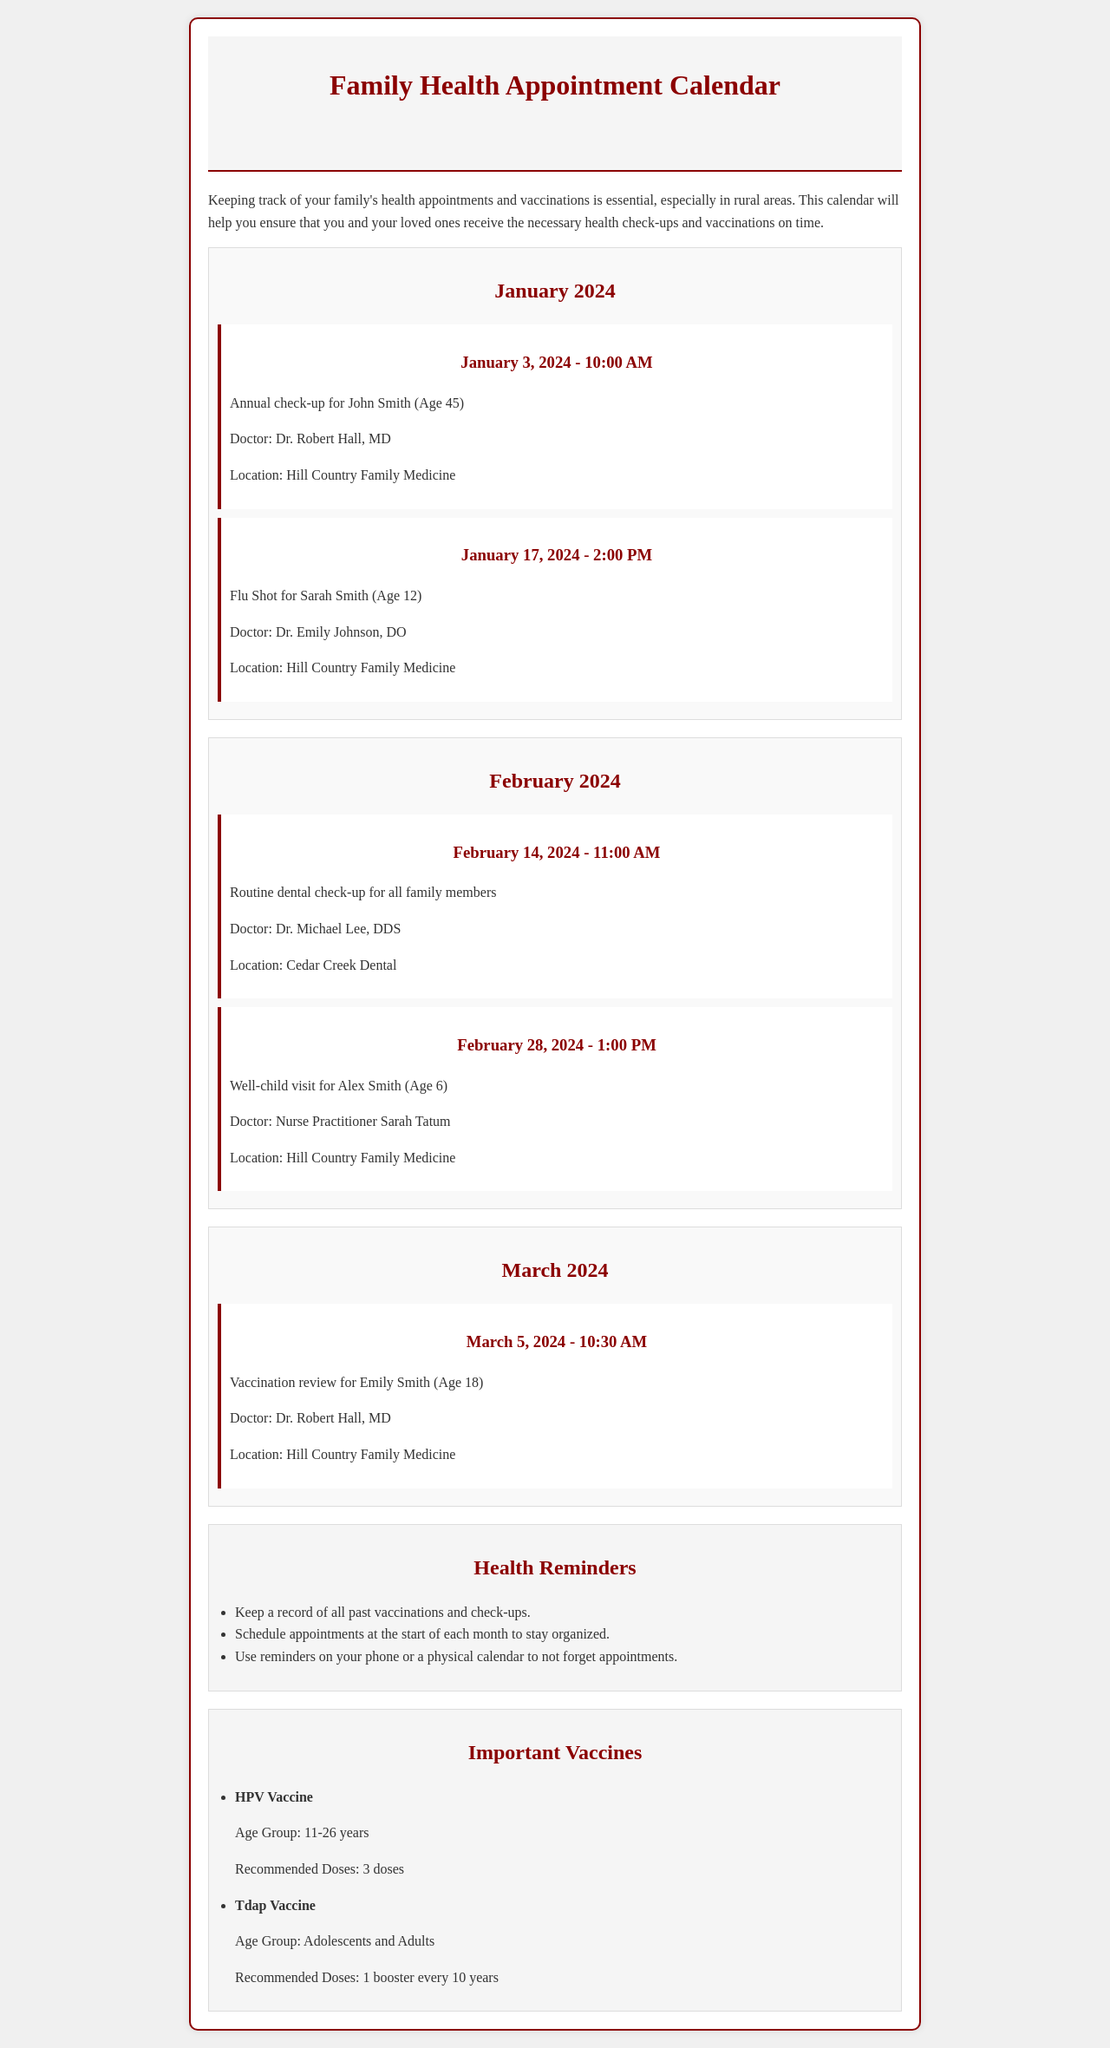what is the date of John's annual check-up? The annual check-up for John Smith is scheduled for January 3, 2024.
Answer: January 3, 2024 who is the doctor for Sarah's flu shot? The doctor administering the flu shot for Sarah Smith is Dr. Emily Johnson, DO.
Answer: Dr. Emily Johnson, DO how many doses are recommended for the HPV vaccine? The HPV vaccine requires a total of 3 doses according to the document.
Answer: 3 doses what time is the dental check-up for the family? The dental check-up is scheduled for 11:00 AM on February 14, 2024.
Answer: 11:00 AM who is the doctor for Alex's well-child visit? The well-child visit for Alex Smith will be conducted by Nurse Practitioner Sarah Tatum.
Answer: Nurse Practitioner Sarah Tatum which month has the vaccination review for Emily? The vaccination review for Emily Smith is scheduled in March 2024.
Answer: March 2024 how often should adults receive the Tdap vaccine booster? The Tdap vaccine booster is recommended every 10 years for adolescents and adults.
Answer: every 10 years what is the location for John's annual check-up? John's annual check-up will take place at Hill Country Family Medicine.
Answer: Hill Country Family Medicine when is the well-child visit for Alex? The well-child visit for Alex Smith is on February 28, 2024, at 1:00 PM.
Answer: February 28, 2024, at 1:00 PM 